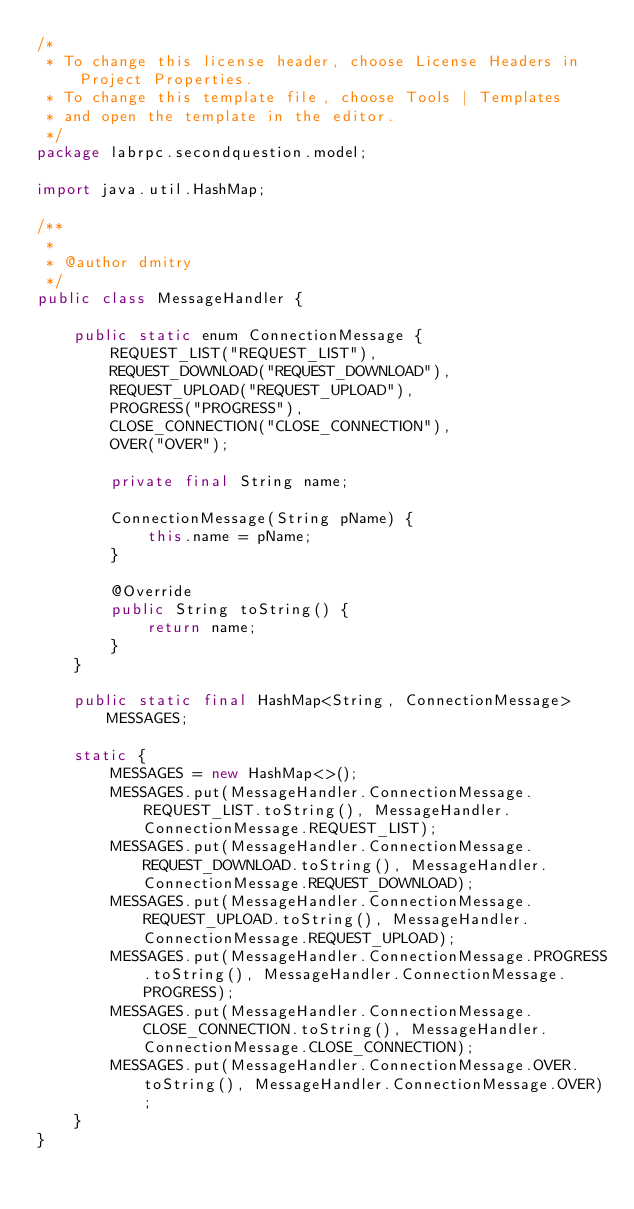<code> <loc_0><loc_0><loc_500><loc_500><_Java_>/*
 * To change this license header, choose License Headers in Project Properties.
 * To change this template file, choose Tools | Templates
 * and open the template in the editor.
 */
package labrpc.secondquestion.model;

import java.util.HashMap;

/**
 *
 * @author dmitry
 */
public class MessageHandler {

    public static enum ConnectionMessage {
        REQUEST_LIST("REQUEST_LIST"),
        REQUEST_DOWNLOAD("REQUEST_DOWNLOAD"),
        REQUEST_UPLOAD("REQUEST_UPLOAD"),
        PROGRESS("PROGRESS"),
        CLOSE_CONNECTION("CLOSE_CONNECTION"),
        OVER("OVER");

        private final String name;

        ConnectionMessage(String pName) {
            this.name = pName;
        }

        @Override
        public String toString() {
            return name;
        }
    }

    public static final HashMap<String, ConnectionMessage> MESSAGES;

    static {
        MESSAGES = new HashMap<>();
        MESSAGES.put(MessageHandler.ConnectionMessage.REQUEST_LIST.toString(), MessageHandler.ConnectionMessage.REQUEST_LIST);
        MESSAGES.put(MessageHandler.ConnectionMessage.REQUEST_DOWNLOAD.toString(), MessageHandler.ConnectionMessage.REQUEST_DOWNLOAD);
        MESSAGES.put(MessageHandler.ConnectionMessage.REQUEST_UPLOAD.toString(), MessageHandler.ConnectionMessage.REQUEST_UPLOAD);
        MESSAGES.put(MessageHandler.ConnectionMessage.PROGRESS.toString(), MessageHandler.ConnectionMessage.PROGRESS);
        MESSAGES.put(MessageHandler.ConnectionMessage.CLOSE_CONNECTION.toString(), MessageHandler.ConnectionMessage.CLOSE_CONNECTION);
        MESSAGES.put(MessageHandler.ConnectionMessage.OVER.toString(), MessageHandler.ConnectionMessage.OVER);
    }
}
</code> 